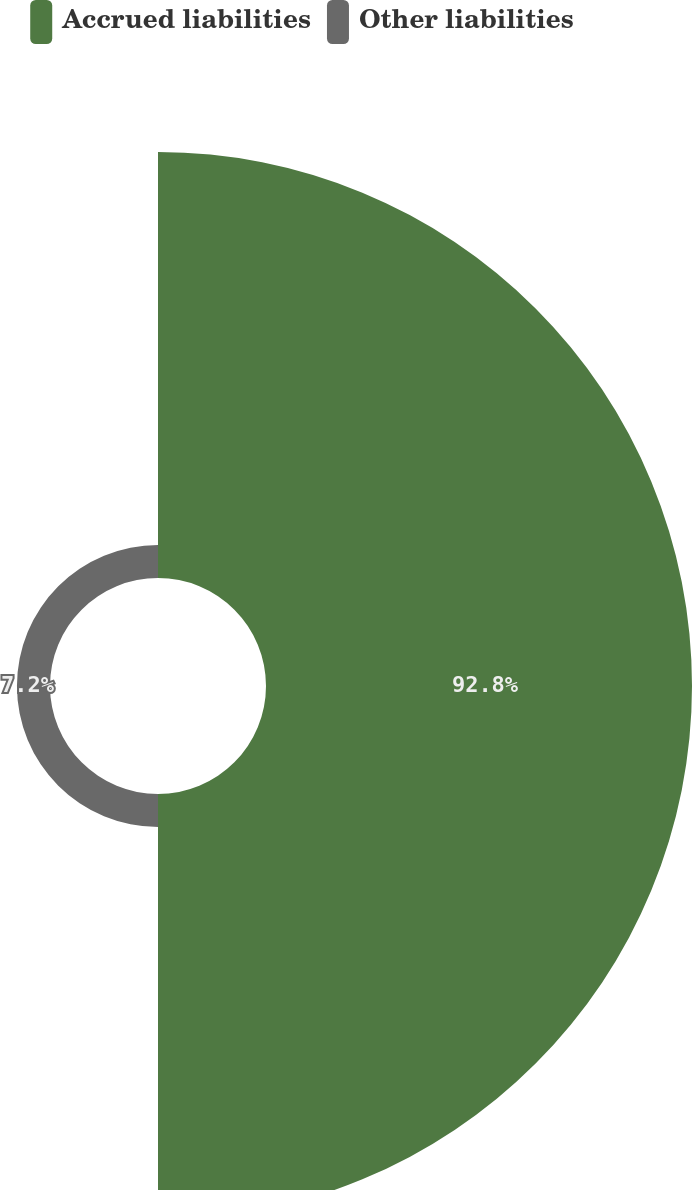Convert chart. <chart><loc_0><loc_0><loc_500><loc_500><pie_chart><fcel>Accrued liabilities<fcel>Other liabilities<nl><fcel>92.8%<fcel>7.2%<nl></chart> 